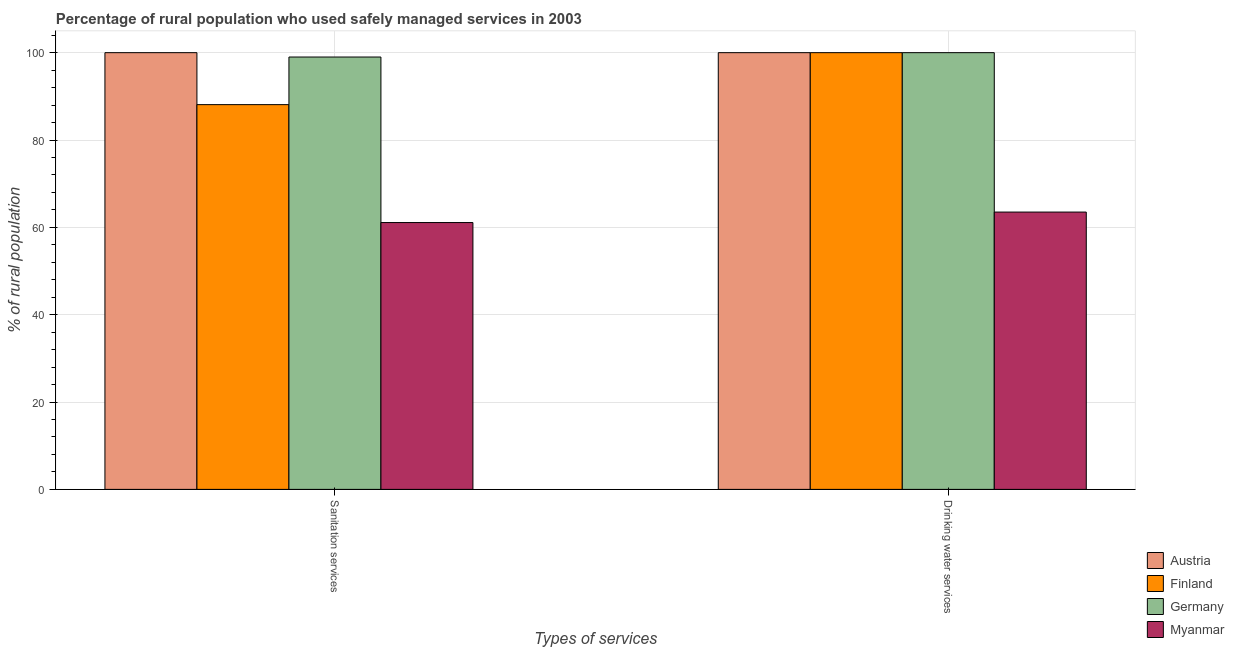How many different coloured bars are there?
Your answer should be very brief. 4. Are the number of bars per tick equal to the number of legend labels?
Offer a terse response. Yes. Are the number of bars on each tick of the X-axis equal?
Give a very brief answer. Yes. How many bars are there on the 1st tick from the left?
Give a very brief answer. 4. How many bars are there on the 2nd tick from the right?
Give a very brief answer. 4. What is the label of the 1st group of bars from the left?
Your response must be concise. Sanitation services. What is the percentage of rural population who used sanitation services in Myanmar?
Your answer should be very brief. 61.1. Across all countries, what is the maximum percentage of rural population who used sanitation services?
Offer a very short reply. 100. Across all countries, what is the minimum percentage of rural population who used drinking water services?
Offer a very short reply. 63.5. In which country was the percentage of rural population who used drinking water services maximum?
Provide a short and direct response. Austria. In which country was the percentage of rural population who used drinking water services minimum?
Your response must be concise. Myanmar. What is the total percentage of rural population who used sanitation services in the graph?
Your response must be concise. 348.2. What is the difference between the percentage of rural population who used drinking water services in Austria and that in Myanmar?
Your answer should be very brief. 36.5. What is the difference between the percentage of rural population who used sanitation services in Austria and the percentage of rural population who used drinking water services in Finland?
Ensure brevity in your answer.  0. What is the average percentage of rural population who used sanitation services per country?
Provide a succinct answer. 87.05. What is the difference between the percentage of rural population who used sanitation services and percentage of rural population who used drinking water services in Myanmar?
Offer a terse response. -2.4. Is the percentage of rural population who used drinking water services in Finland less than that in Germany?
Ensure brevity in your answer.  No. What does the 3rd bar from the left in Sanitation services represents?
Provide a succinct answer. Germany. What does the 4th bar from the right in Sanitation services represents?
Offer a terse response. Austria. How many bars are there?
Your answer should be compact. 8. How many countries are there in the graph?
Your answer should be compact. 4. What is the difference between two consecutive major ticks on the Y-axis?
Offer a very short reply. 20. Are the values on the major ticks of Y-axis written in scientific E-notation?
Make the answer very short. No. Does the graph contain any zero values?
Offer a very short reply. No. Does the graph contain grids?
Provide a succinct answer. Yes. Where does the legend appear in the graph?
Keep it short and to the point. Bottom right. How are the legend labels stacked?
Offer a terse response. Vertical. What is the title of the graph?
Keep it short and to the point. Percentage of rural population who used safely managed services in 2003. What is the label or title of the X-axis?
Provide a succinct answer. Types of services. What is the label or title of the Y-axis?
Your response must be concise. % of rural population. What is the % of rural population in Austria in Sanitation services?
Keep it short and to the point. 100. What is the % of rural population in Finland in Sanitation services?
Make the answer very short. 88.1. What is the % of rural population in Germany in Sanitation services?
Offer a terse response. 99. What is the % of rural population of Myanmar in Sanitation services?
Your answer should be compact. 61.1. What is the % of rural population in Myanmar in Drinking water services?
Offer a terse response. 63.5. Across all Types of services, what is the maximum % of rural population of Myanmar?
Make the answer very short. 63.5. Across all Types of services, what is the minimum % of rural population in Austria?
Ensure brevity in your answer.  100. Across all Types of services, what is the minimum % of rural population of Finland?
Make the answer very short. 88.1. Across all Types of services, what is the minimum % of rural population in Germany?
Offer a terse response. 99. Across all Types of services, what is the minimum % of rural population in Myanmar?
Ensure brevity in your answer.  61.1. What is the total % of rural population of Austria in the graph?
Your response must be concise. 200. What is the total % of rural population in Finland in the graph?
Provide a succinct answer. 188.1. What is the total % of rural population of Germany in the graph?
Offer a terse response. 199. What is the total % of rural population in Myanmar in the graph?
Keep it short and to the point. 124.6. What is the difference between the % of rural population of Germany in Sanitation services and that in Drinking water services?
Give a very brief answer. -1. What is the difference between the % of rural population in Austria in Sanitation services and the % of rural population in Finland in Drinking water services?
Your answer should be compact. 0. What is the difference between the % of rural population in Austria in Sanitation services and the % of rural population in Myanmar in Drinking water services?
Your answer should be compact. 36.5. What is the difference between the % of rural population in Finland in Sanitation services and the % of rural population in Germany in Drinking water services?
Provide a short and direct response. -11.9. What is the difference between the % of rural population in Finland in Sanitation services and the % of rural population in Myanmar in Drinking water services?
Offer a terse response. 24.6. What is the difference between the % of rural population of Germany in Sanitation services and the % of rural population of Myanmar in Drinking water services?
Keep it short and to the point. 35.5. What is the average % of rural population in Austria per Types of services?
Your answer should be compact. 100. What is the average % of rural population of Finland per Types of services?
Provide a succinct answer. 94.05. What is the average % of rural population of Germany per Types of services?
Your answer should be very brief. 99.5. What is the average % of rural population of Myanmar per Types of services?
Provide a short and direct response. 62.3. What is the difference between the % of rural population of Austria and % of rural population of Myanmar in Sanitation services?
Offer a terse response. 38.9. What is the difference between the % of rural population in Finland and % of rural population in Germany in Sanitation services?
Your response must be concise. -10.9. What is the difference between the % of rural population of Finland and % of rural population of Myanmar in Sanitation services?
Provide a succinct answer. 27. What is the difference between the % of rural population in Germany and % of rural population in Myanmar in Sanitation services?
Provide a short and direct response. 37.9. What is the difference between the % of rural population of Austria and % of rural population of Myanmar in Drinking water services?
Provide a short and direct response. 36.5. What is the difference between the % of rural population of Finland and % of rural population of Myanmar in Drinking water services?
Provide a short and direct response. 36.5. What is the difference between the % of rural population in Germany and % of rural population in Myanmar in Drinking water services?
Your response must be concise. 36.5. What is the ratio of the % of rural population of Austria in Sanitation services to that in Drinking water services?
Offer a terse response. 1. What is the ratio of the % of rural population in Finland in Sanitation services to that in Drinking water services?
Provide a succinct answer. 0.88. What is the ratio of the % of rural population in Myanmar in Sanitation services to that in Drinking water services?
Offer a terse response. 0.96. What is the difference between the highest and the second highest % of rural population in Finland?
Provide a short and direct response. 11.9. What is the difference between the highest and the lowest % of rural population in Germany?
Provide a succinct answer. 1. 